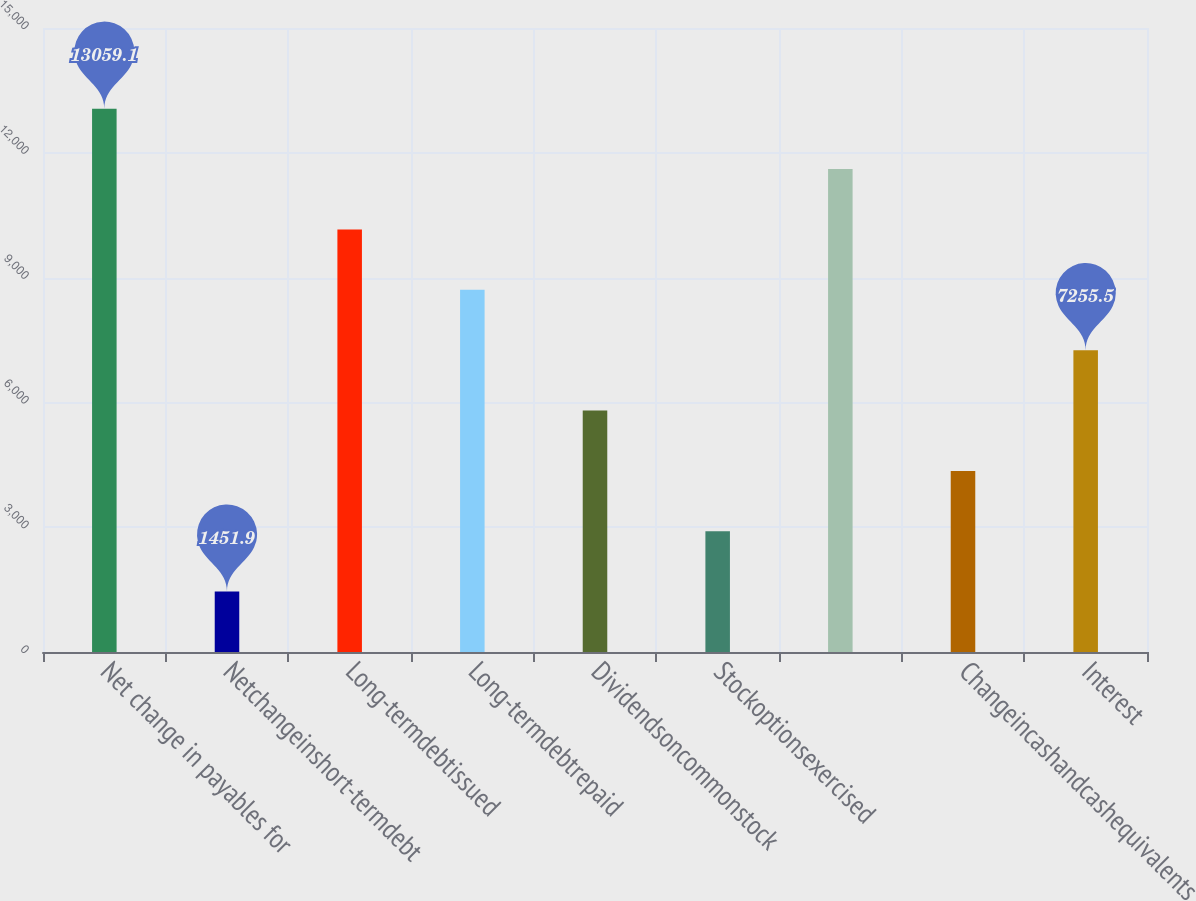<chart> <loc_0><loc_0><loc_500><loc_500><bar_chart><fcel>Net change in payables for<fcel>Netchangeinshort-termdebt<fcel>Long-termdebtissued<fcel>Long-termdebtrepaid<fcel>Dividendsoncommonstock<fcel>Stockoptionsexercised<fcel>Unnamed: 6<fcel>Changeincashandcashequivalents<fcel>Interest<nl><fcel>13059.1<fcel>1451.9<fcel>10157.3<fcel>8706.4<fcel>5804.6<fcel>2902.8<fcel>11608.2<fcel>4353.7<fcel>7255.5<nl></chart> 